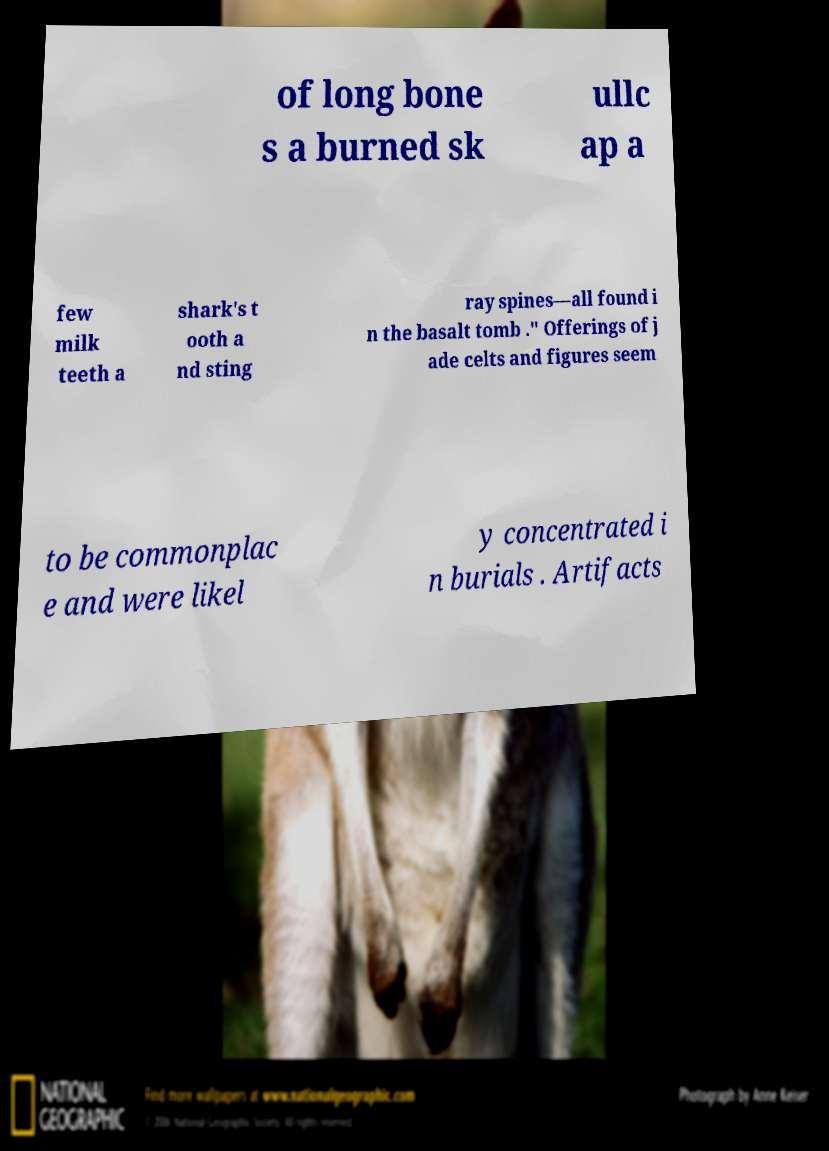There's text embedded in this image that I need extracted. Can you transcribe it verbatim? of long bone s a burned sk ullc ap a few milk teeth a shark's t ooth a nd sting ray spines—all found i n the basalt tomb ." Offerings of j ade celts and figures seem to be commonplac e and were likel y concentrated i n burials . Artifacts 